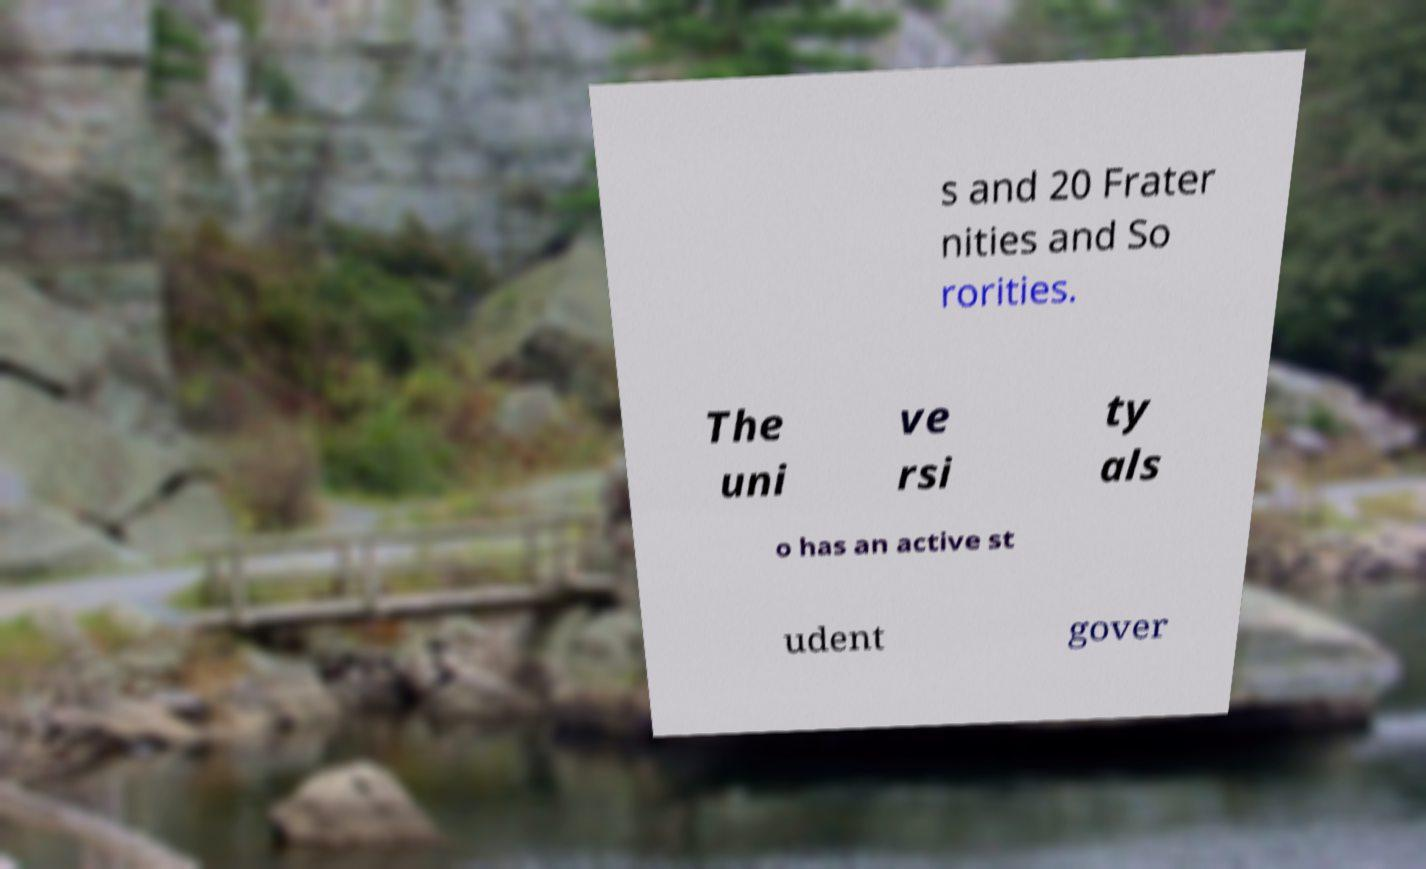Can you accurately transcribe the text from the provided image for me? s and 20 Frater nities and So rorities. The uni ve rsi ty als o has an active st udent gover 